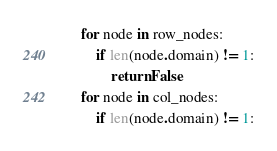Convert code to text. <code><loc_0><loc_0><loc_500><loc_500><_Python_>    for node in row_nodes:
        if len(node.domain) != 1:
            return False
    for node in col_nodes:
        if len(node.domain) != 1:</code> 